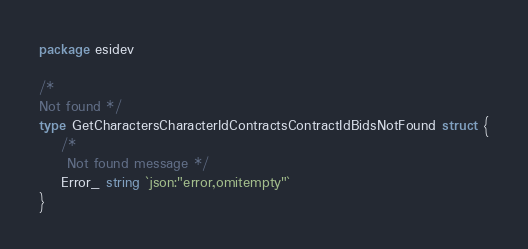Convert code to text. <code><loc_0><loc_0><loc_500><loc_500><_Go_>package esidev

/*
Not found */
type GetCharactersCharacterIdContractsContractIdBidsNotFound struct {
	/*
	 Not found message */
	Error_ string `json:"error,omitempty"`
}
</code> 